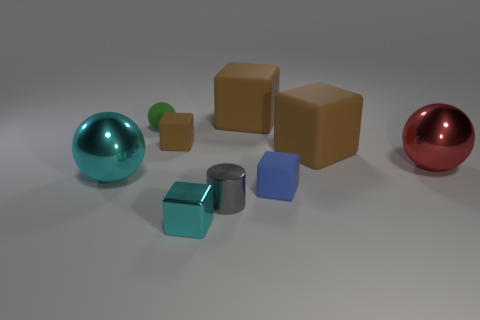What size is the red sphere that is made of the same material as the cyan sphere?
Offer a terse response. Large. What is the size of the shiny object that is the same color as the small metallic block?
Your answer should be very brief. Large. Does the small cylinder have the same color as the metal block?
Provide a succinct answer. No. There is a cube that is in front of the blue thing that is right of the small sphere; are there any small gray shiny things that are to the left of it?
Your answer should be very brief. No. How many cyan metal blocks have the same size as the blue rubber object?
Your answer should be compact. 1. There is a sphere behind the red thing; does it have the same size as the blue block that is on the right side of the gray metallic thing?
Provide a short and direct response. Yes. There is a big object that is both behind the large cyan thing and on the left side of the blue rubber cube; what is its shape?
Provide a short and direct response. Cube. Are there any metallic blocks that have the same color as the cylinder?
Offer a terse response. No. Are any things visible?
Provide a succinct answer. Yes. The large metallic thing that is to the left of the red sphere is what color?
Ensure brevity in your answer.  Cyan. 